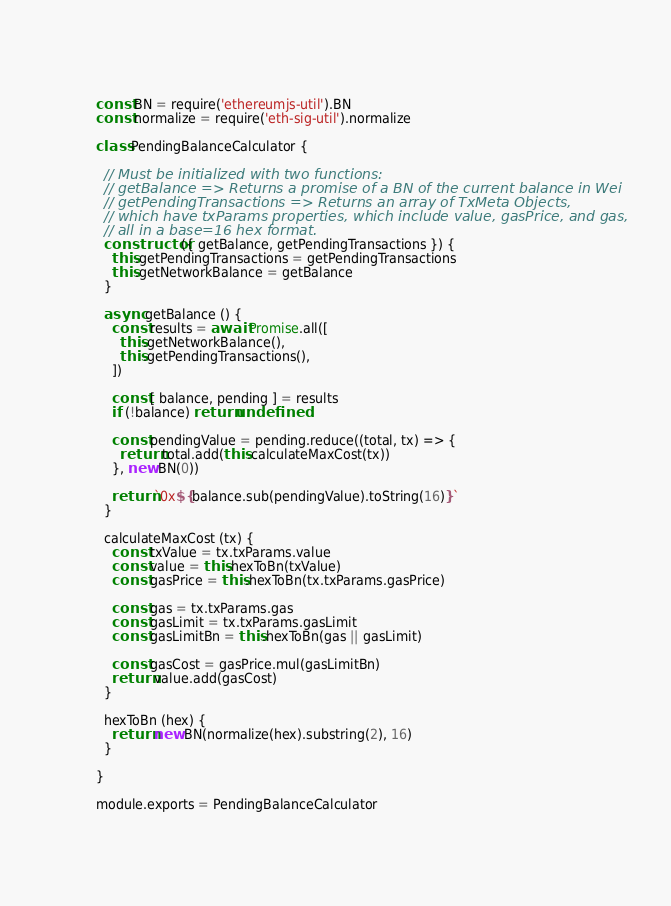Convert code to text. <code><loc_0><loc_0><loc_500><loc_500><_JavaScript_>const BN = require('ethereumjs-util').BN
const normalize = require('eth-sig-util').normalize

class PendingBalanceCalculator {

  // Must be initialized with two functions:
  // getBalance => Returns a promise of a BN of the current balance in Wei
  // getPendingTransactions => Returns an array of TxMeta Objects,
  // which have txParams properties, which include value, gasPrice, and gas,
  // all in a base=16 hex format.
  constructor ({ getBalance, getPendingTransactions }) {
    this.getPendingTransactions = getPendingTransactions
    this.getNetworkBalance = getBalance
  }

  async getBalance () {
    const results = await Promise.all([
      this.getNetworkBalance(),
      this.getPendingTransactions(),
    ])

    const [ balance, pending ] = results
    if (!balance) return undefined

    const pendingValue = pending.reduce((total, tx) => {
      return total.add(this.calculateMaxCost(tx))
    }, new BN(0))

    return `0x${balance.sub(pendingValue).toString(16)}`
  }

  calculateMaxCost (tx) {
    const txValue = tx.txParams.value
    const value = this.hexToBn(txValue)
    const gasPrice = this.hexToBn(tx.txParams.gasPrice)

    const gas = tx.txParams.gas
    const gasLimit = tx.txParams.gasLimit
    const gasLimitBn = this.hexToBn(gas || gasLimit)

    const gasCost = gasPrice.mul(gasLimitBn)
    return value.add(gasCost)
  }

  hexToBn (hex) {
    return new BN(normalize(hex).substring(2), 16)
  }

}

module.exports = PendingBalanceCalculator
</code> 